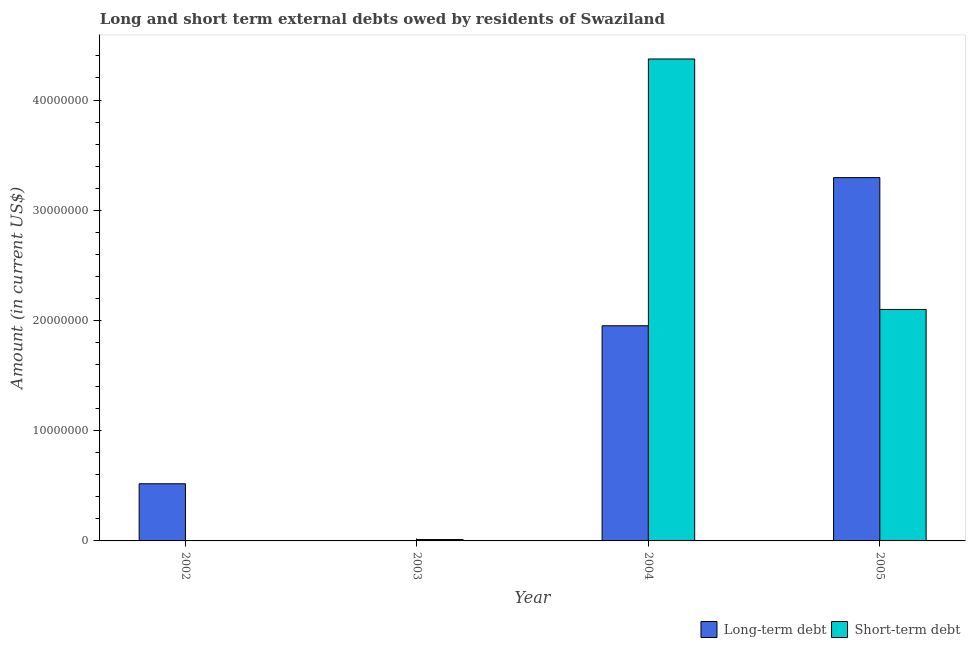How many different coloured bars are there?
Offer a terse response. 2. What is the long-term debts owed by residents in 2003?
Offer a terse response. 0. Across all years, what is the maximum long-term debts owed by residents?
Give a very brief answer. 3.30e+07. In which year was the short-term debts owed by residents maximum?
Keep it short and to the point. 2004. What is the total long-term debts owed by residents in the graph?
Offer a very short reply. 5.77e+07. What is the difference between the long-term debts owed by residents in 2002 and that in 2004?
Ensure brevity in your answer.  -1.43e+07. What is the difference between the long-term debts owed by residents in 2004 and the short-term debts owed by residents in 2002?
Your answer should be very brief. 1.43e+07. What is the average short-term debts owed by residents per year?
Give a very brief answer. 1.62e+07. In the year 2004, what is the difference between the long-term debts owed by residents and short-term debts owed by residents?
Your response must be concise. 0. What is the ratio of the long-term debts owed by residents in 2002 to that in 2005?
Give a very brief answer. 0.16. Is the short-term debts owed by residents in 2004 less than that in 2005?
Provide a short and direct response. No. Is the difference between the long-term debts owed by residents in 2004 and 2005 greater than the difference between the short-term debts owed by residents in 2004 and 2005?
Keep it short and to the point. No. What is the difference between the highest and the second highest short-term debts owed by residents?
Ensure brevity in your answer.  2.27e+07. What is the difference between the highest and the lowest short-term debts owed by residents?
Your response must be concise. 4.37e+07. Are all the bars in the graph horizontal?
Your answer should be very brief. No. What is the difference between two consecutive major ticks on the Y-axis?
Provide a short and direct response. 1.00e+07. Are the values on the major ticks of Y-axis written in scientific E-notation?
Provide a succinct answer. No. Does the graph contain any zero values?
Your answer should be compact. Yes. Does the graph contain grids?
Keep it short and to the point. No. How many legend labels are there?
Your response must be concise. 2. What is the title of the graph?
Give a very brief answer. Long and short term external debts owed by residents of Swaziland. Does "Start a business" appear as one of the legend labels in the graph?
Offer a terse response. No. What is the Amount (in current US$) in Long-term debt in 2002?
Offer a terse response. 5.19e+06. What is the Amount (in current US$) in Short-term debt in 2003?
Make the answer very short. 1.25e+05. What is the Amount (in current US$) in Long-term debt in 2004?
Your answer should be compact. 1.95e+07. What is the Amount (in current US$) of Short-term debt in 2004?
Offer a very short reply. 4.37e+07. What is the Amount (in current US$) in Long-term debt in 2005?
Keep it short and to the point. 3.30e+07. What is the Amount (in current US$) in Short-term debt in 2005?
Ensure brevity in your answer.  2.10e+07. Across all years, what is the maximum Amount (in current US$) of Long-term debt?
Provide a succinct answer. 3.30e+07. Across all years, what is the maximum Amount (in current US$) in Short-term debt?
Offer a terse response. 4.37e+07. Across all years, what is the minimum Amount (in current US$) in Short-term debt?
Offer a terse response. 0. What is the total Amount (in current US$) of Long-term debt in the graph?
Your response must be concise. 5.77e+07. What is the total Amount (in current US$) of Short-term debt in the graph?
Your answer should be compact. 6.48e+07. What is the difference between the Amount (in current US$) of Long-term debt in 2002 and that in 2004?
Ensure brevity in your answer.  -1.43e+07. What is the difference between the Amount (in current US$) in Long-term debt in 2002 and that in 2005?
Provide a short and direct response. -2.78e+07. What is the difference between the Amount (in current US$) in Short-term debt in 2003 and that in 2004?
Make the answer very short. -4.36e+07. What is the difference between the Amount (in current US$) in Short-term debt in 2003 and that in 2005?
Give a very brief answer. -2.09e+07. What is the difference between the Amount (in current US$) in Long-term debt in 2004 and that in 2005?
Your answer should be compact. -1.34e+07. What is the difference between the Amount (in current US$) of Short-term debt in 2004 and that in 2005?
Give a very brief answer. 2.27e+07. What is the difference between the Amount (in current US$) of Long-term debt in 2002 and the Amount (in current US$) of Short-term debt in 2003?
Make the answer very short. 5.06e+06. What is the difference between the Amount (in current US$) of Long-term debt in 2002 and the Amount (in current US$) of Short-term debt in 2004?
Make the answer very short. -3.85e+07. What is the difference between the Amount (in current US$) of Long-term debt in 2002 and the Amount (in current US$) of Short-term debt in 2005?
Offer a very short reply. -1.58e+07. What is the difference between the Amount (in current US$) in Long-term debt in 2004 and the Amount (in current US$) in Short-term debt in 2005?
Offer a terse response. -1.48e+06. What is the average Amount (in current US$) of Long-term debt per year?
Give a very brief answer. 1.44e+07. What is the average Amount (in current US$) in Short-term debt per year?
Your response must be concise. 1.62e+07. In the year 2004, what is the difference between the Amount (in current US$) in Long-term debt and Amount (in current US$) in Short-term debt?
Your response must be concise. -2.42e+07. In the year 2005, what is the difference between the Amount (in current US$) in Long-term debt and Amount (in current US$) in Short-term debt?
Provide a succinct answer. 1.20e+07. What is the ratio of the Amount (in current US$) of Long-term debt in 2002 to that in 2004?
Offer a terse response. 0.27. What is the ratio of the Amount (in current US$) of Long-term debt in 2002 to that in 2005?
Offer a terse response. 0.16. What is the ratio of the Amount (in current US$) in Short-term debt in 2003 to that in 2004?
Offer a terse response. 0. What is the ratio of the Amount (in current US$) of Short-term debt in 2003 to that in 2005?
Your answer should be compact. 0.01. What is the ratio of the Amount (in current US$) of Long-term debt in 2004 to that in 2005?
Keep it short and to the point. 0.59. What is the ratio of the Amount (in current US$) in Short-term debt in 2004 to that in 2005?
Offer a very short reply. 2.08. What is the difference between the highest and the second highest Amount (in current US$) of Long-term debt?
Your response must be concise. 1.34e+07. What is the difference between the highest and the second highest Amount (in current US$) in Short-term debt?
Give a very brief answer. 2.27e+07. What is the difference between the highest and the lowest Amount (in current US$) in Long-term debt?
Your answer should be very brief. 3.30e+07. What is the difference between the highest and the lowest Amount (in current US$) in Short-term debt?
Keep it short and to the point. 4.37e+07. 